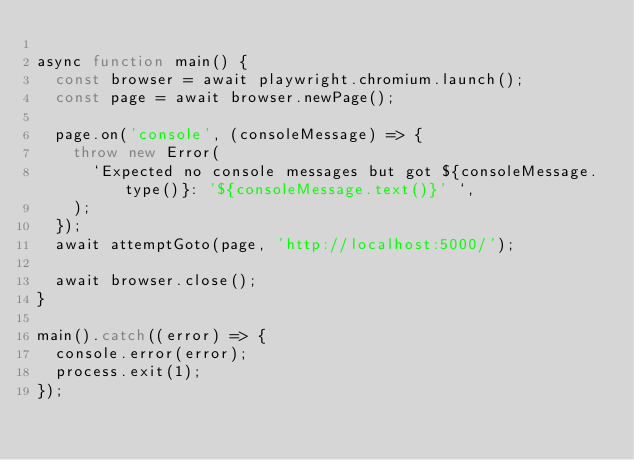<code> <loc_0><loc_0><loc_500><loc_500><_JavaScript_>
async function main() {
  const browser = await playwright.chromium.launch();
  const page = await browser.newPage();

  page.on('console', (consoleMessage) => {
    throw new Error(
      `Expected no console messages but got ${consoleMessage.type()}: '${consoleMessage.text()}' `,
    );
  });
  await attemptGoto(page, 'http://localhost:5000/');

  await browser.close();
}

main().catch((error) => {
  console.error(error);
  process.exit(1);
});
</code> 